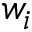<formula> <loc_0><loc_0><loc_500><loc_500>w _ { i }</formula> 